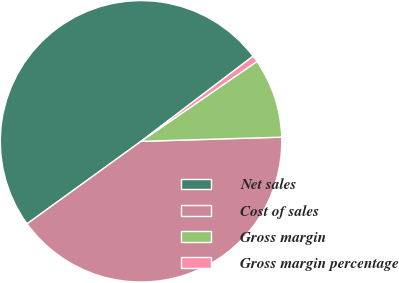<chart> <loc_0><loc_0><loc_500><loc_500><pie_chart><fcel>Net sales<fcel>Cost of sales<fcel>Gross margin<fcel>Gross margin percentage<nl><fcel>49.63%<fcel>40.5%<fcel>9.13%<fcel>0.74%<nl></chart> 